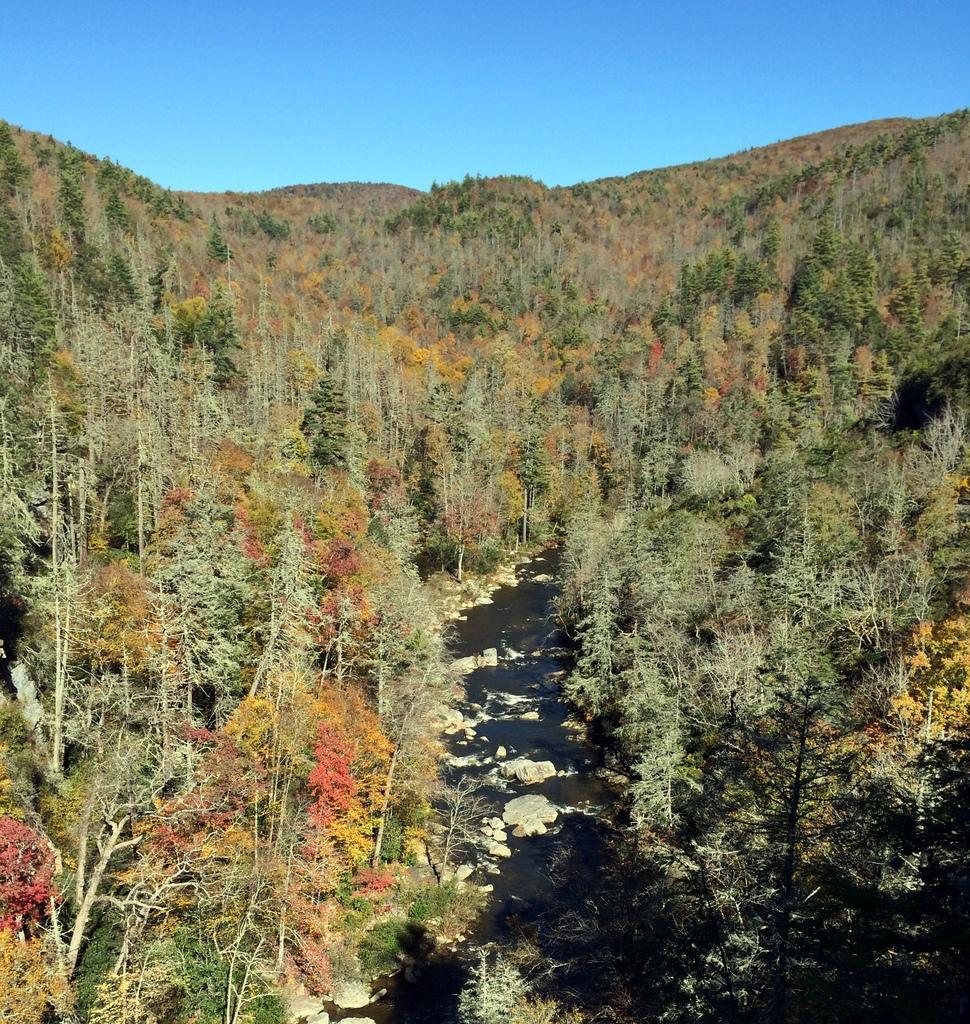Describe this image in one or two sentences. In the image we can see there are trees and path in between and the sky. 